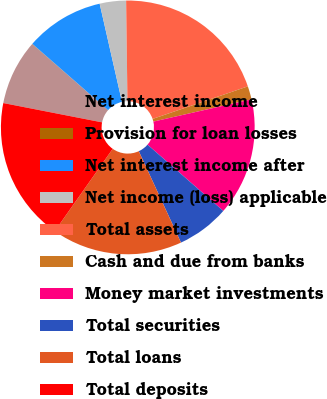Convert chart. <chart><loc_0><loc_0><loc_500><loc_500><pie_chart><fcel>Net interest income<fcel>Provision for loan losses<fcel>Net interest income after<fcel>Net income (loss) applicable<fcel>Total assets<fcel>Cash and due from banks<fcel>Money market investments<fcel>Total securities<fcel>Total loans<fcel>Total deposits<nl><fcel>8.34%<fcel>0.03%<fcel>10.0%<fcel>3.35%<fcel>19.97%<fcel>1.69%<fcel>14.99%<fcel>6.68%<fcel>16.65%<fcel>18.31%<nl></chart> 